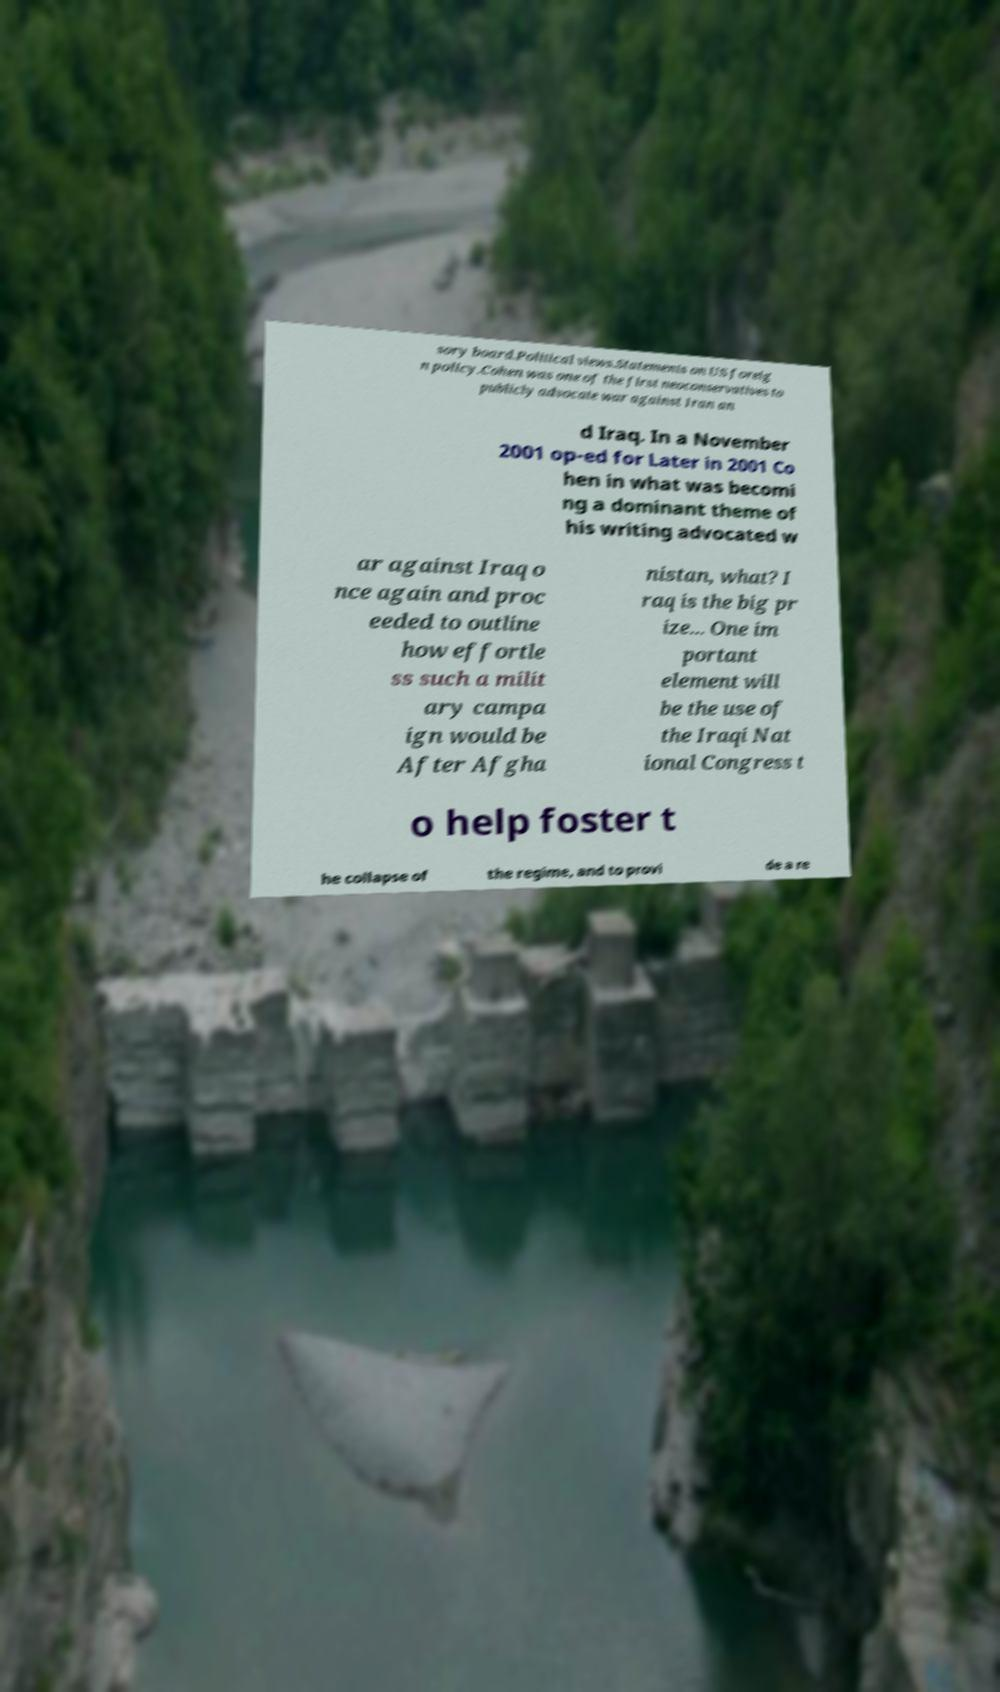Could you extract and type out the text from this image? sory board.Political views.Statements on US foreig n policy.Cohen was one of the first neoconservatives to publicly advocate war against Iran an d Iraq. In a November 2001 op-ed for Later in 2001 Co hen in what was becomi ng a dominant theme of his writing advocated w ar against Iraq o nce again and proc eeded to outline how effortle ss such a milit ary campa ign would be After Afgha nistan, what? I raq is the big pr ize... One im portant element will be the use of the Iraqi Nat ional Congress t o help foster t he collapse of the regime, and to provi de a re 